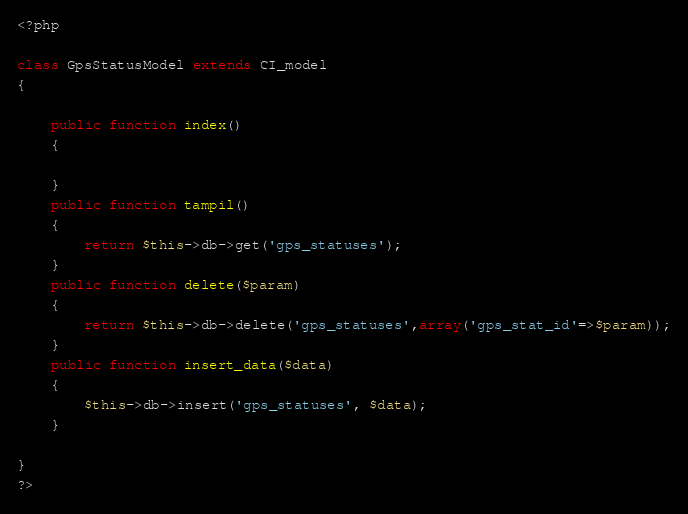Convert code to text. <code><loc_0><loc_0><loc_500><loc_500><_PHP_><?php

class GpsStatusModel extends CI_model
{
	
	public function index()
	{

	}
	public function tampil()
	{
		return $this->db->get('gps_statuses');
	}
	public function delete($param)
	{
		return $this->db->delete('gps_statuses',array('gps_stat_id'=>$param));
	}
	public function insert_data($data)
	{
		$this->db->insert('gps_statuses', $data);
	}
	
}
?></code> 